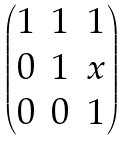<formula> <loc_0><loc_0><loc_500><loc_500>\begin{pmatrix} 1 & 1 & 1 \\ 0 & 1 & x \\ 0 & 0 & 1 \end{pmatrix}</formula> 